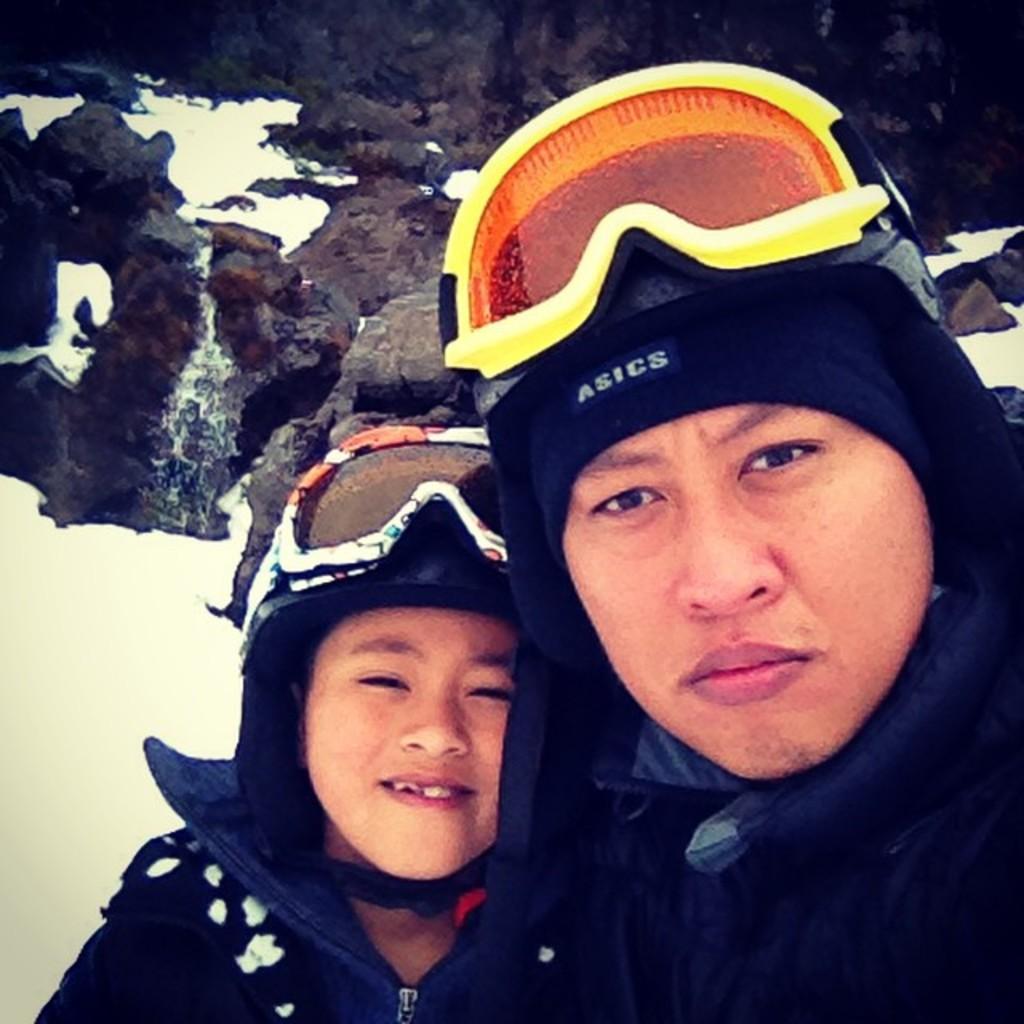Describe this image in one or two sentences. In the image two persons are standing and smiling. Behind them there are some hills and there is snow. 